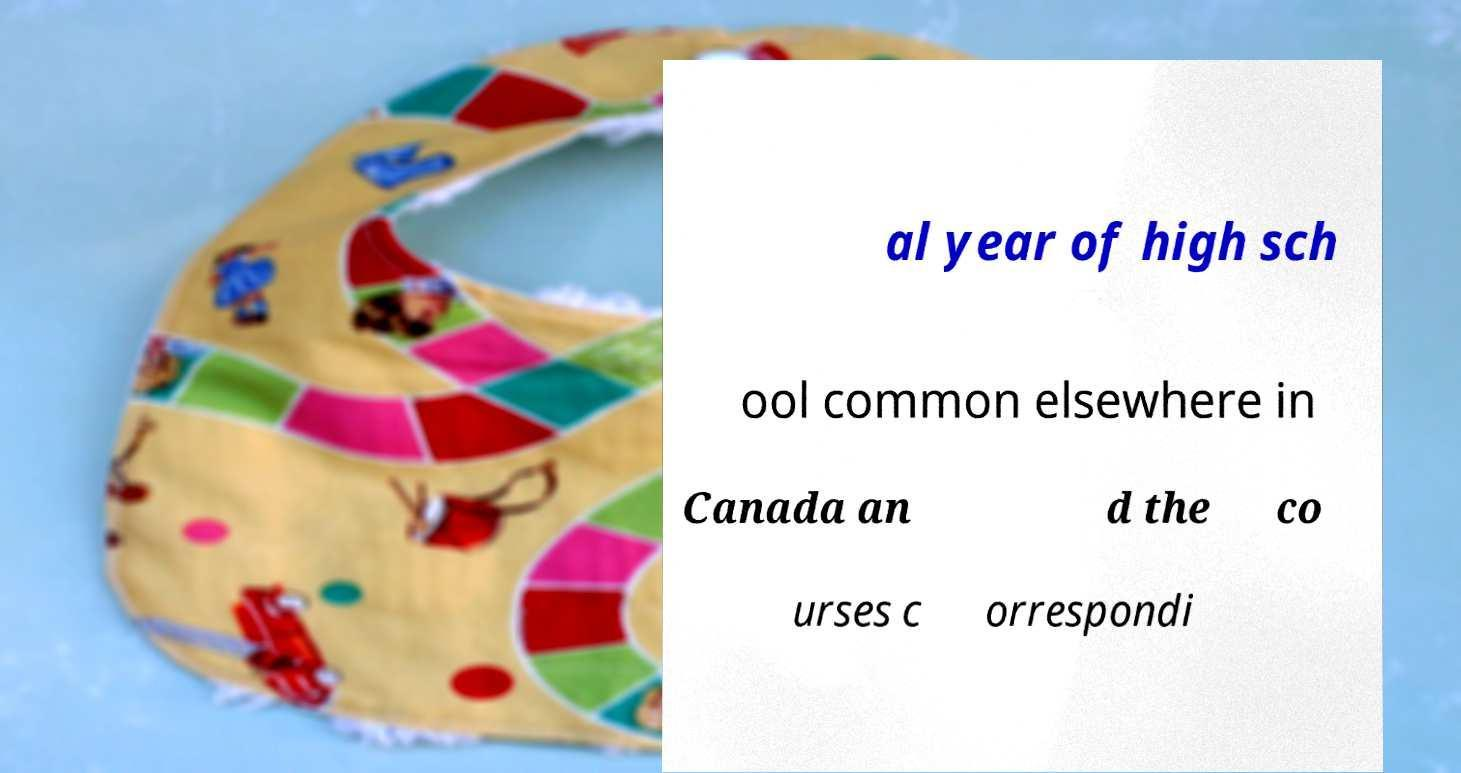Please read and relay the text visible in this image. What does it say? al year of high sch ool common elsewhere in Canada an d the co urses c orrespondi 